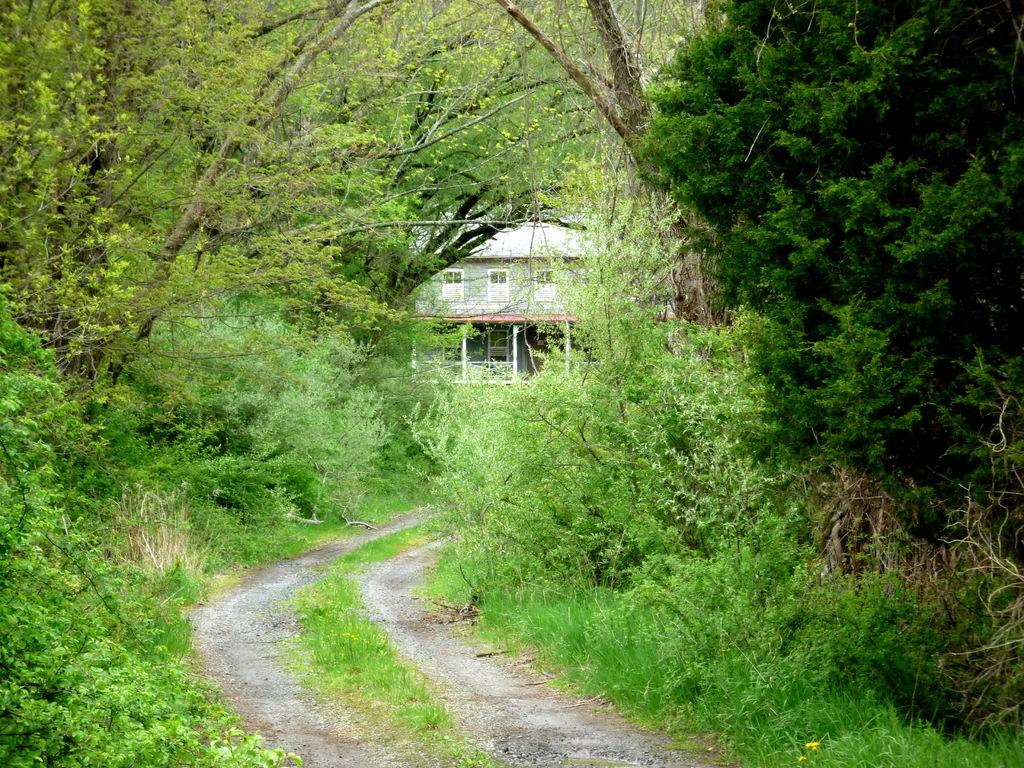What is the primary feature of the image? The primary feature of the image is the many trees. Can you describe any paths or walkways in the image? Yes, there is a small walking passage at the bottom of the image. Is there any man-made structure visible in the image? Yes, there is a small white-colored house in the image. What type of lawyer is standing next to the house in the image? There is no lawyer present in the image; it only features trees, a walking passage, and a small white-colored house. 